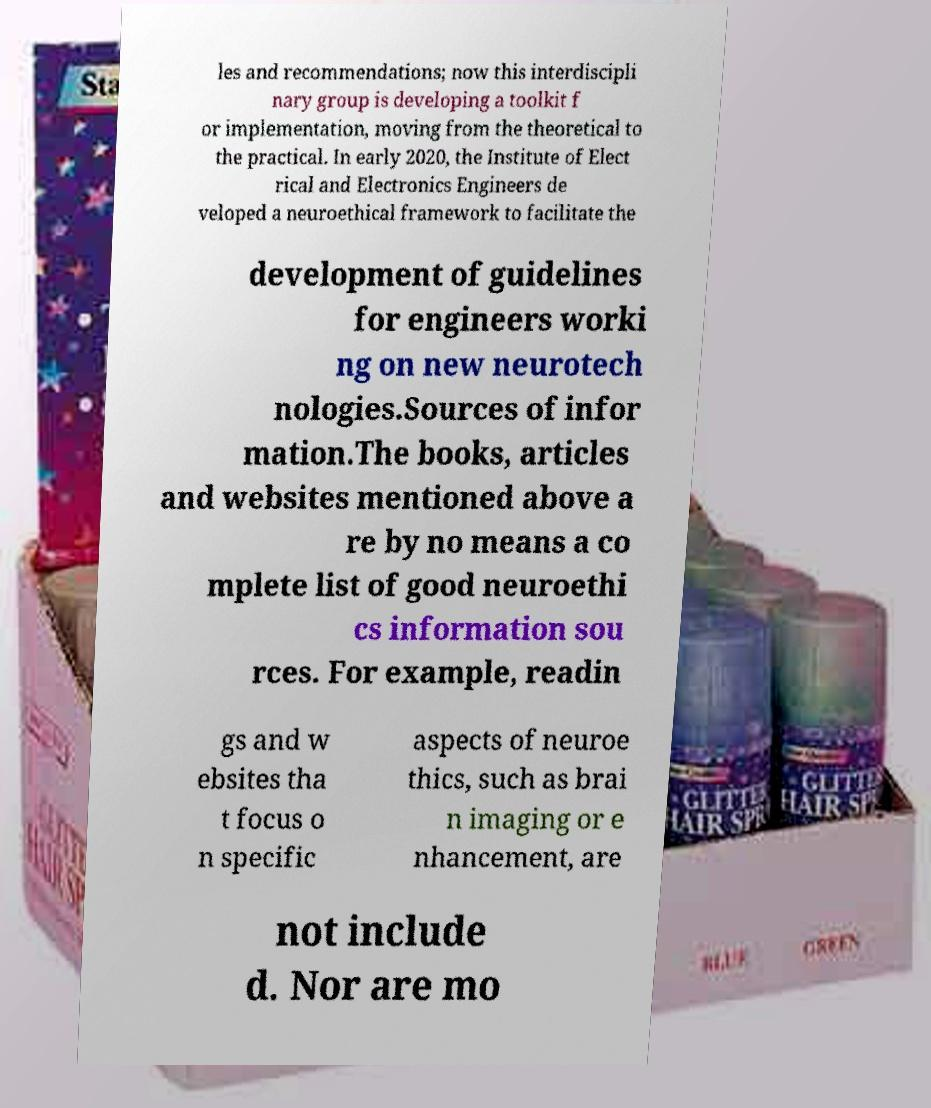Please read and relay the text visible in this image. What does it say? les and recommendations; now this interdiscipli nary group is developing a toolkit f or implementation, moving from the theoretical to the practical. In early 2020, the Institute of Elect rical and Electronics Engineers de veloped a neuroethical framework to facilitate the development of guidelines for engineers worki ng on new neurotech nologies.Sources of infor mation.The books, articles and websites mentioned above a re by no means a co mplete list of good neuroethi cs information sou rces. For example, readin gs and w ebsites tha t focus o n specific aspects of neuroe thics, such as brai n imaging or e nhancement, are not include d. Nor are mo 